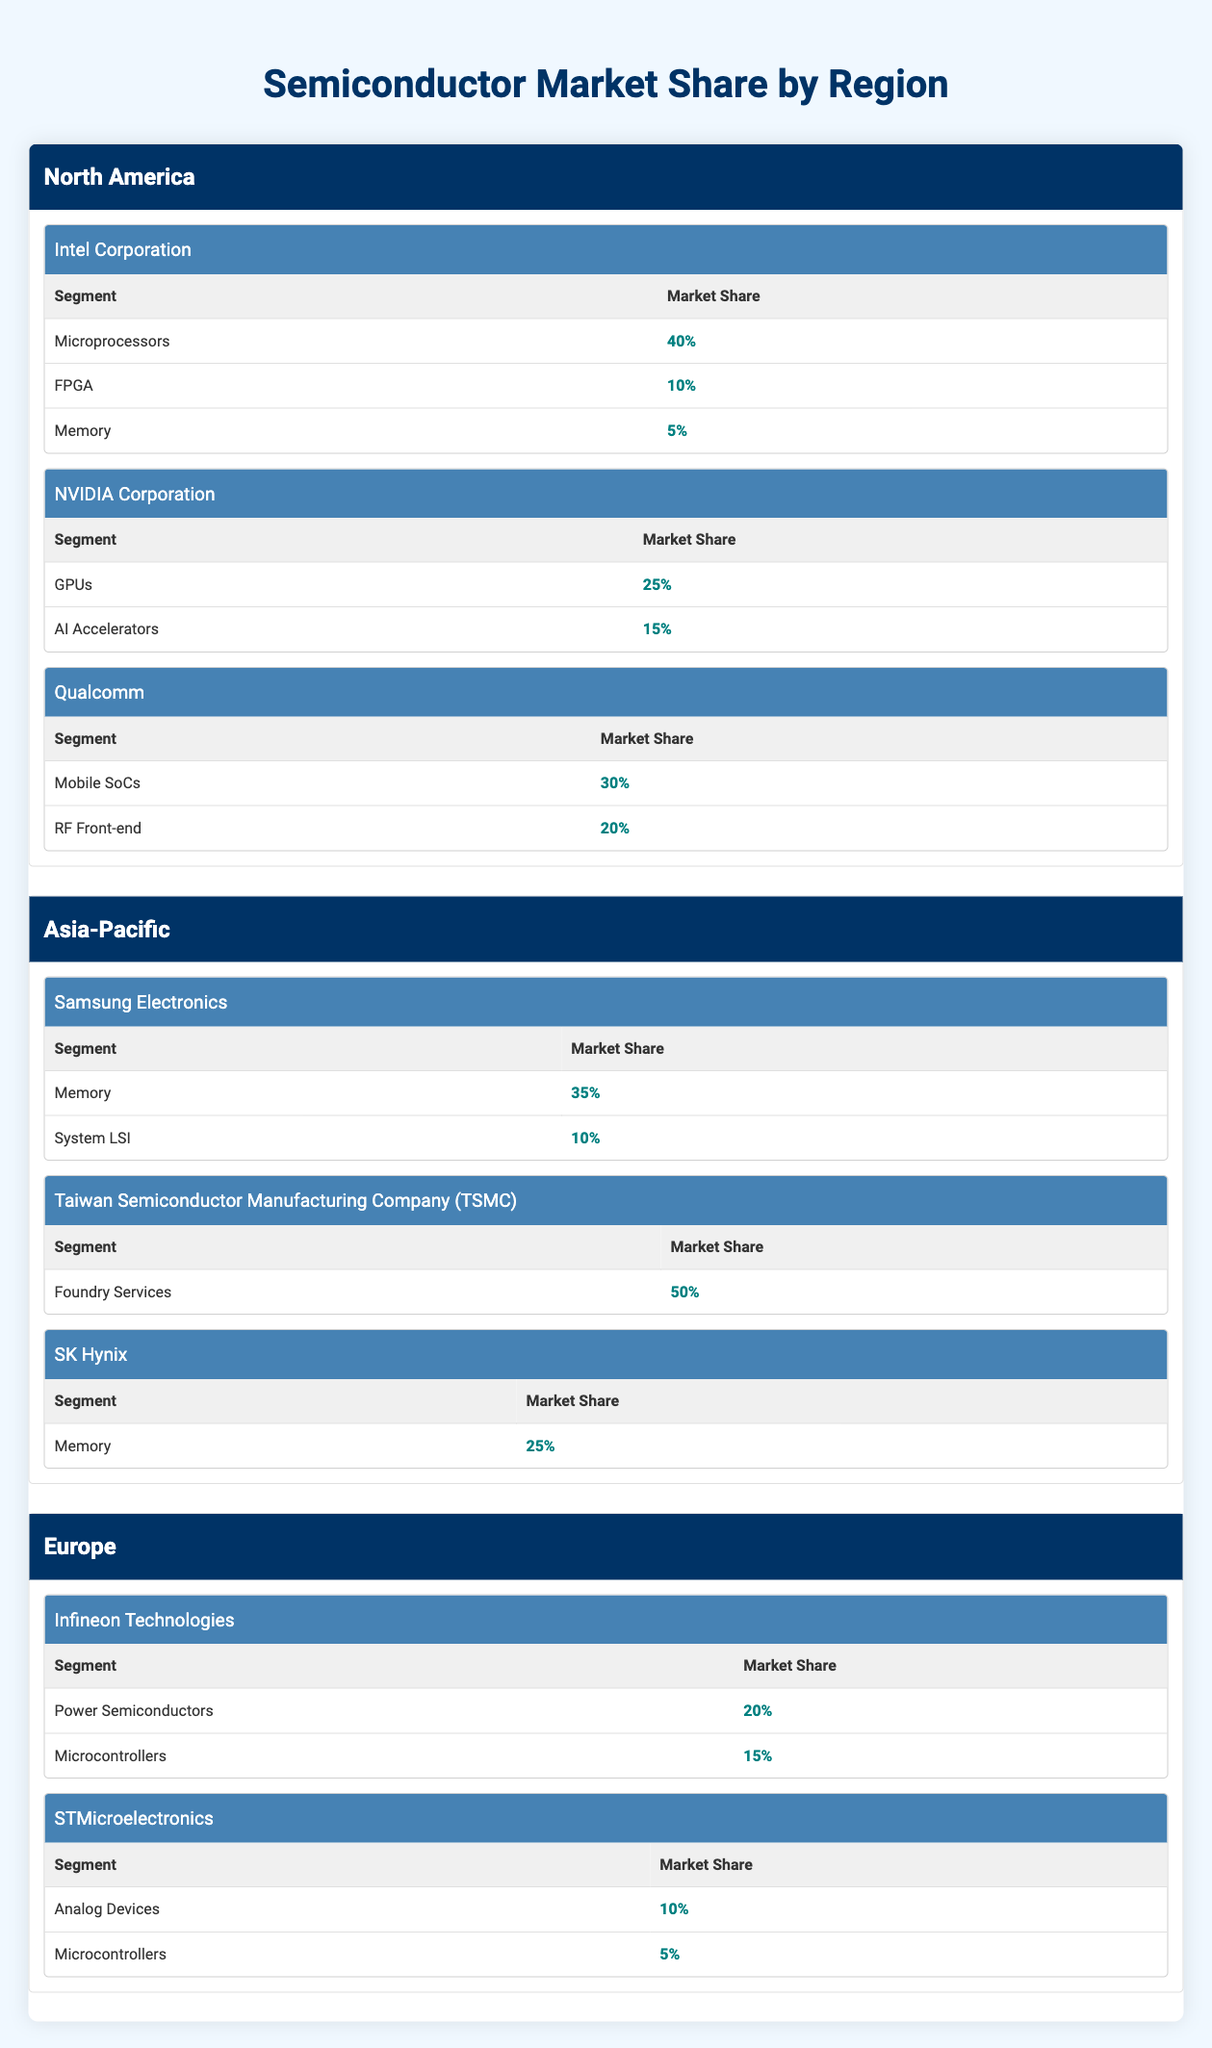What is Intel Corporation's market share in Microprocessors? From the table under North America, Intel Corporation has a market share of 40% specifically for the Microprocessors segment.
Answer: 40% Which company has the highest market share in the Asia-Pacific region? Looking at the Asia-Pacific section, Taiwan Semiconductor Manufacturing Company (TSMC) has a market share of 50% in Foundry Services, which is the highest among the listed companies in that region.
Answer: TSMC What is the total market share of Qualcomm in North America? To find this, we add Qualcomm's market shares in its segments: Mobile SoCs (30%) + RF Front-end (20%) = 50%.
Answer: 50% Is SK Hynix engaged in the Microprocessor segment? By checking the Asia-Pacific section for SK Hynix, it is listed only under the Memory segment, indicating no involvement in the Microprocessor segment.
Answer: No What is the combined market share of Infineon Technologies in its two segments? Infineon Technologies has market shares of 20% in Power Semiconductors and 15% in Microcontrollers. Adding these together gives us 20% + 15% = 35%.
Answer: 35% Which company has a higher market share in Memory, Samsung Electronics or SK Hynix? Samsung Electronics has 35% and SK Hynix has 25% in the Memory segment. Since 35% is greater than 25%, Samsung Electronics has a higher market share.
Answer: Samsung Electronics What percentage of the market shares in North America is attributed to microprocessors and FPGAs combined? Adding Intel's Microprocessors (40%) and FPGAs (10%) gives us 40% + 10% = 50% as the total percentage from these segments in North America.
Answer: 50% Does STMicroelectronics have a presence in the Memory segment? The table under Europe only shows STMicroelectronics with segments in Analog Devices and Microcontrollers, so there is no involvement in the Memory segment.
Answer: No What is the overall market share of all companies listed in Europe? Summing up the market shares for the companies listed in Europe: Infineon Technologies (20% + 15% = 35%) and STMicroelectronics (10% + 5% = 15%). Their totals are 35% + 15% = 50%.
Answer: 50% 